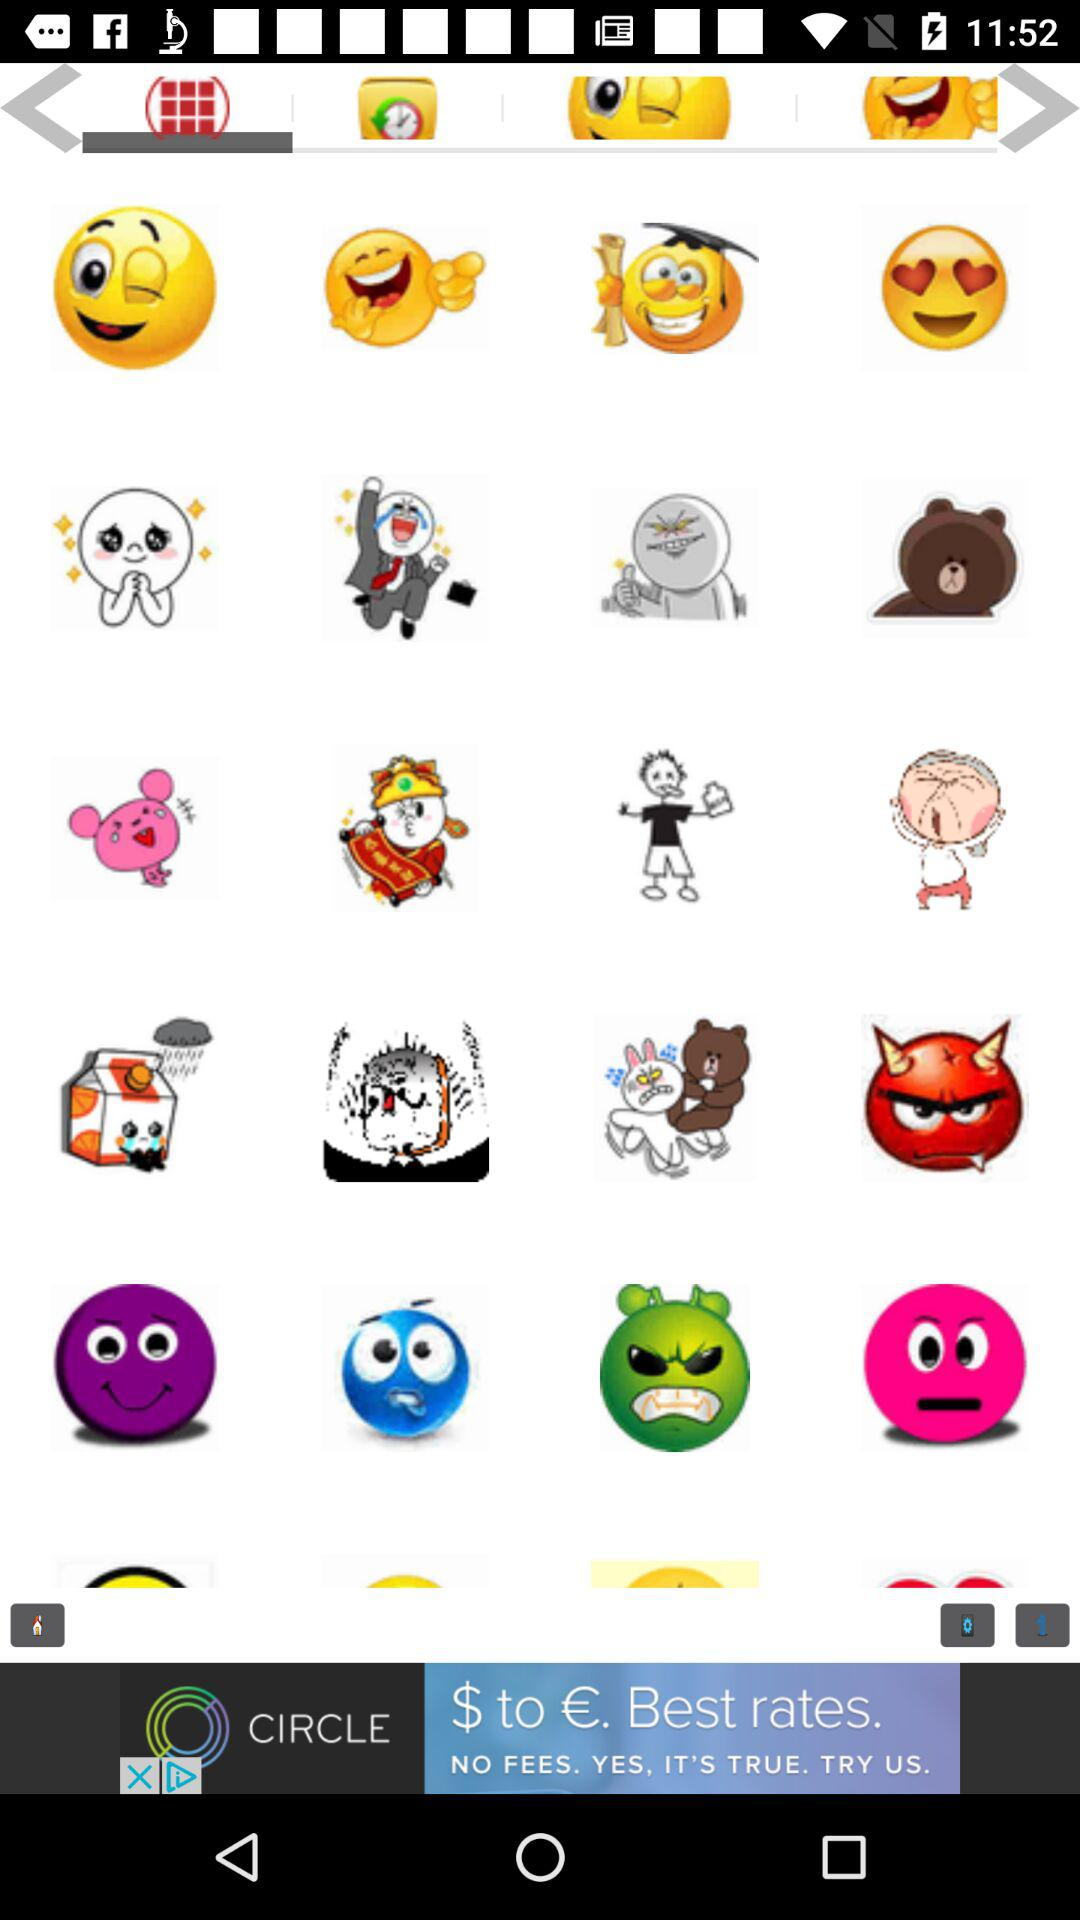How many more smiley faces with a wink and a smirk are there than smiley faces with heart shaped eyes?
Answer the question using a single word or phrase. 1 